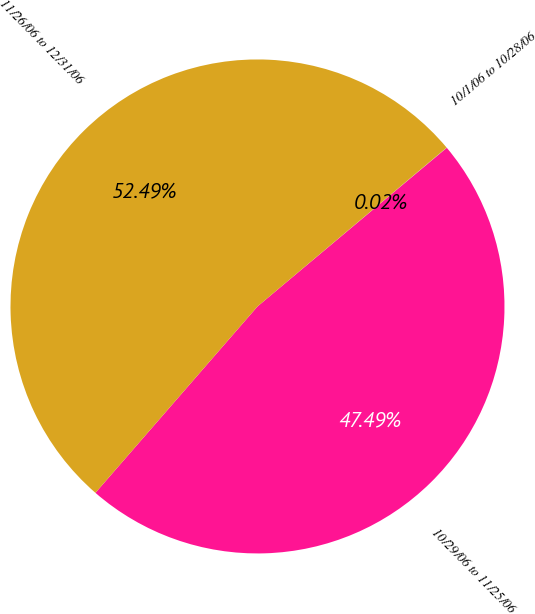Convert chart to OTSL. <chart><loc_0><loc_0><loc_500><loc_500><pie_chart><fcel>10/1/06 to 10/28/06<fcel>10/29/06 to 11/25/06<fcel>11/26/06 to 12/31/06<nl><fcel>0.02%<fcel>47.49%<fcel>52.49%<nl></chart> 